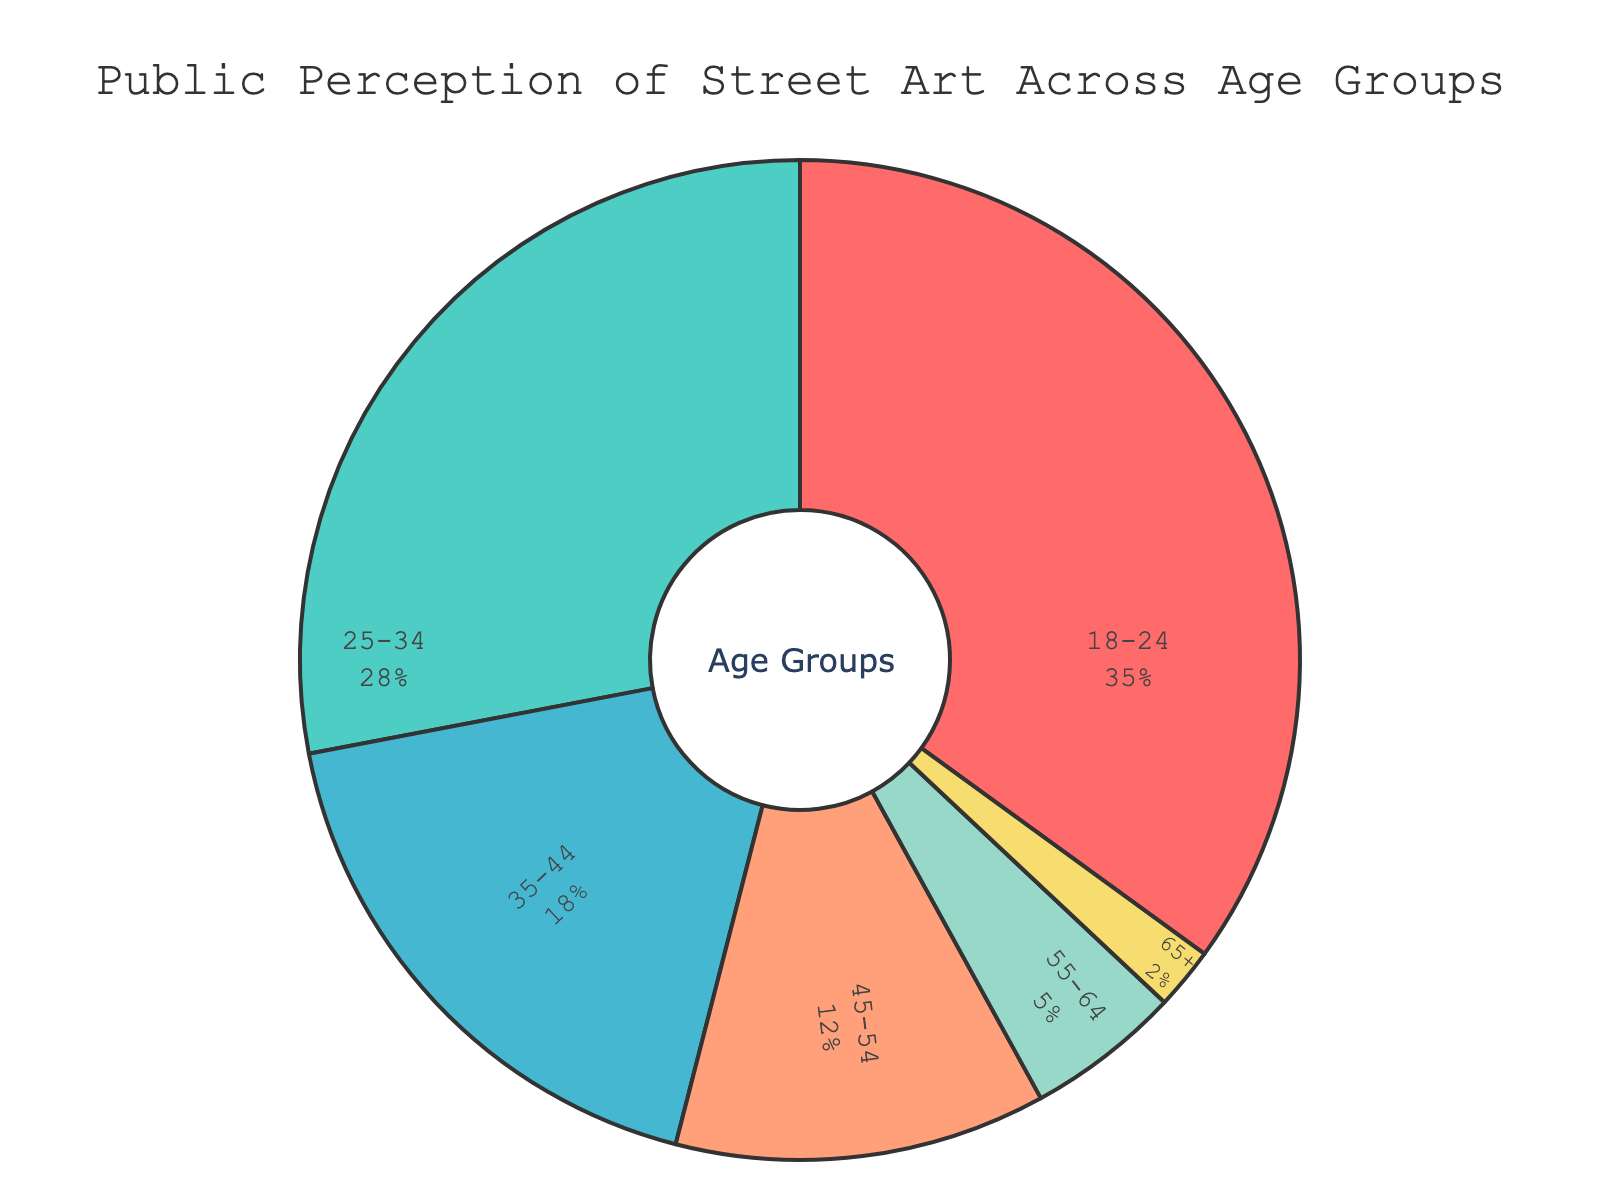Which age group has the largest perception of street art? Looking at the pie chart, the largest segment corresponds to the 18-24 age group, which occupies the largest area.
Answer: 18-24 What is the combined percentage of people aged 35-44 and 45-54 who have a perception of street art? According to the figure, the percentage for 35-44 is 18% and for 45-54 is 12%. Therefore, their combined percentage is 18% + 12%.
Answer: 30% Compare the perception of street art between the age groups 25-34 and 55-64. Which group has a higher percentage? The pie chart shows that the 25-34 age group has a percentage of 28%, whereas the 55-64 age group has just 5%. Thus, 25-34 has a higher percentage.
Answer: 25-34 What is the difference in percentage between the two extremes, 18-24 and 65+? The pie chart indicates the percentage for 18-24 is 35%, and for 65+ is 2%. The difference can be found by subtracting the smaller percentage from the larger one, so 35% - 2%.
Answer: 33% What percentage of people aged 45 and above have a perception of street art? Summing the percentages of the relevant groups, we have 45-54 at 12%, 55-64 at 5%, and 65+ at 2%. This adds up to 12% + 5% + 2%.
Answer: 19% Identify the color used for the 35-44 age group and describe its visual effect in the chart. The pie chart uses a light blue color for the 35-44 age group, which provides a calming and distinct appearance compared to the other bright and darker colors.
Answer: Light blue What proportion of the chart is taken up by age groups 55-64 and 65+ combined? From the pie chart, 55-64 shows 5% and 65+ shows 2%. The combined proportion can be calculated by adding these values, resulting in 5% + 2%.
Answer: 7% If the 25-34 and 35-44 age groups were combined into a single group, what percentage would they form in the pie chart? The existing percentages in the pie chart are 28% for 25-34 and 18% for 35-44. Summing these percentages gives us 28% + 18%.
Answer: 46% Between the age groups 45-54 and 65+, which one represents a smaller percentage in the chart, and by how much? The chart shows that 45-54 has a percentage of 12% while 65+ has 2%. To find the difference, subtract the smaller percentage from the larger one: 12% - 2%.
Answer: 65+ by 10% 